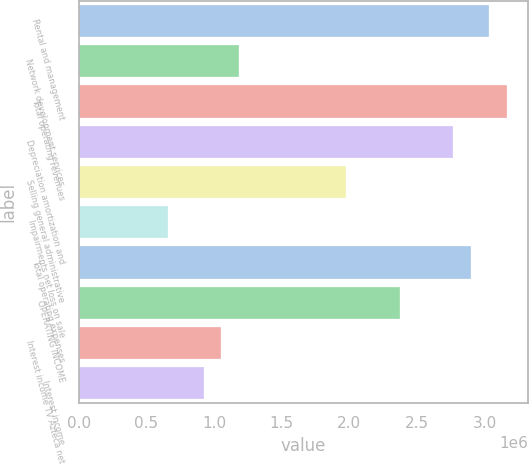Convert chart. <chart><loc_0><loc_0><loc_500><loc_500><bar_chart><fcel>Rental and management<fcel>Network development services<fcel>Total operating revenues<fcel>Depreciation amortization and<fcel>Selling general administrative<fcel>Impairments net loss on sale<fcel>Total operating expenses<fcel>OPERATING INCOME<fcel>Interest income TV Azteca net<fcel>Interest income<nl><fcel>3.02999e+06<fcel>1.18565e+06<fcel>3.16172e+06<fcel>2.76651e+06<fcel>1.97608e+06<fcel>658693<fcel>2.89825e+06<fcel>2.37129e+06<fcel>1.05391e+06<fcel>922169<nl></chart> 